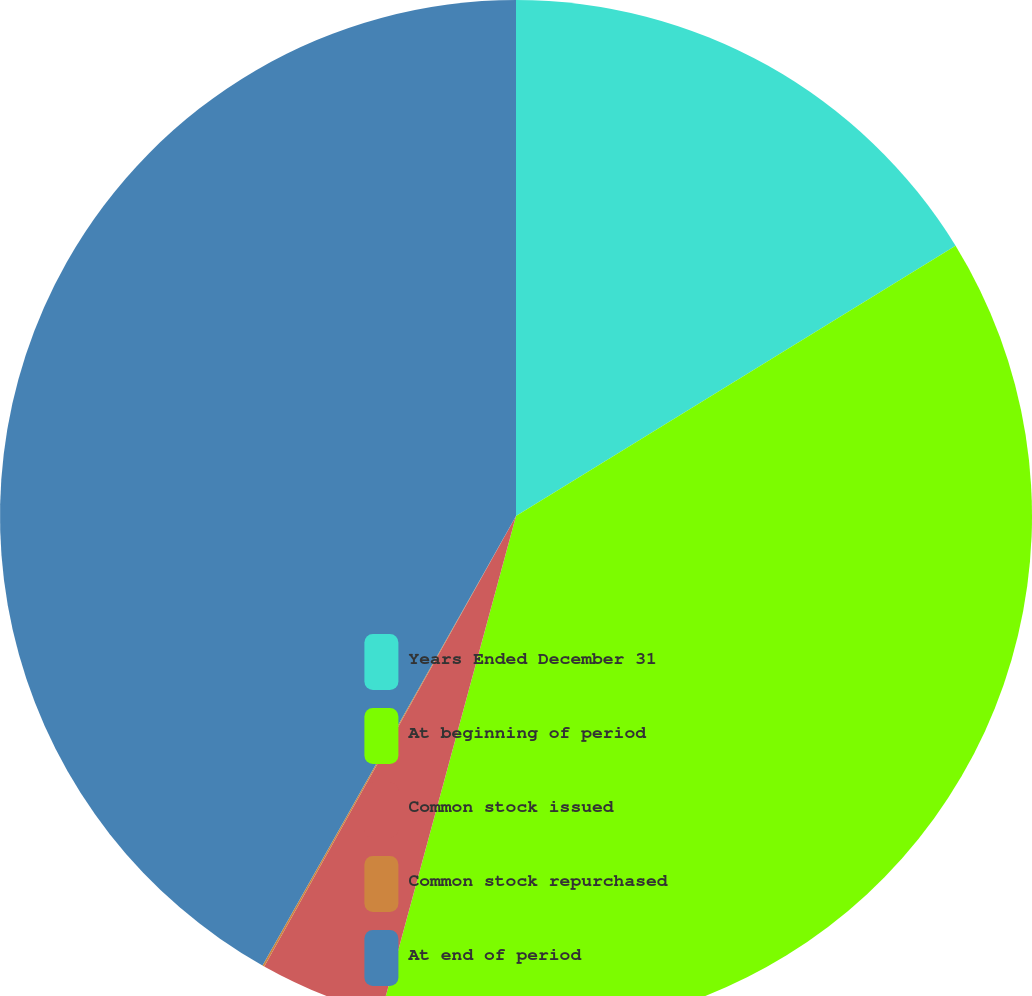Convert chart. <chart><loc_0><loc_0><loc_500><loc_500><pie_chart><fcel>Years Ended December 31<fcel>At beginning of period<fcel>Common stock issued<fcel>Common stock repurchased<fcel>At end of period<nl><fcel>16.23%<fcel>37.99%<fcel>3.9%<fcel>0.06%<fcel>41.83%<nl></chart> 